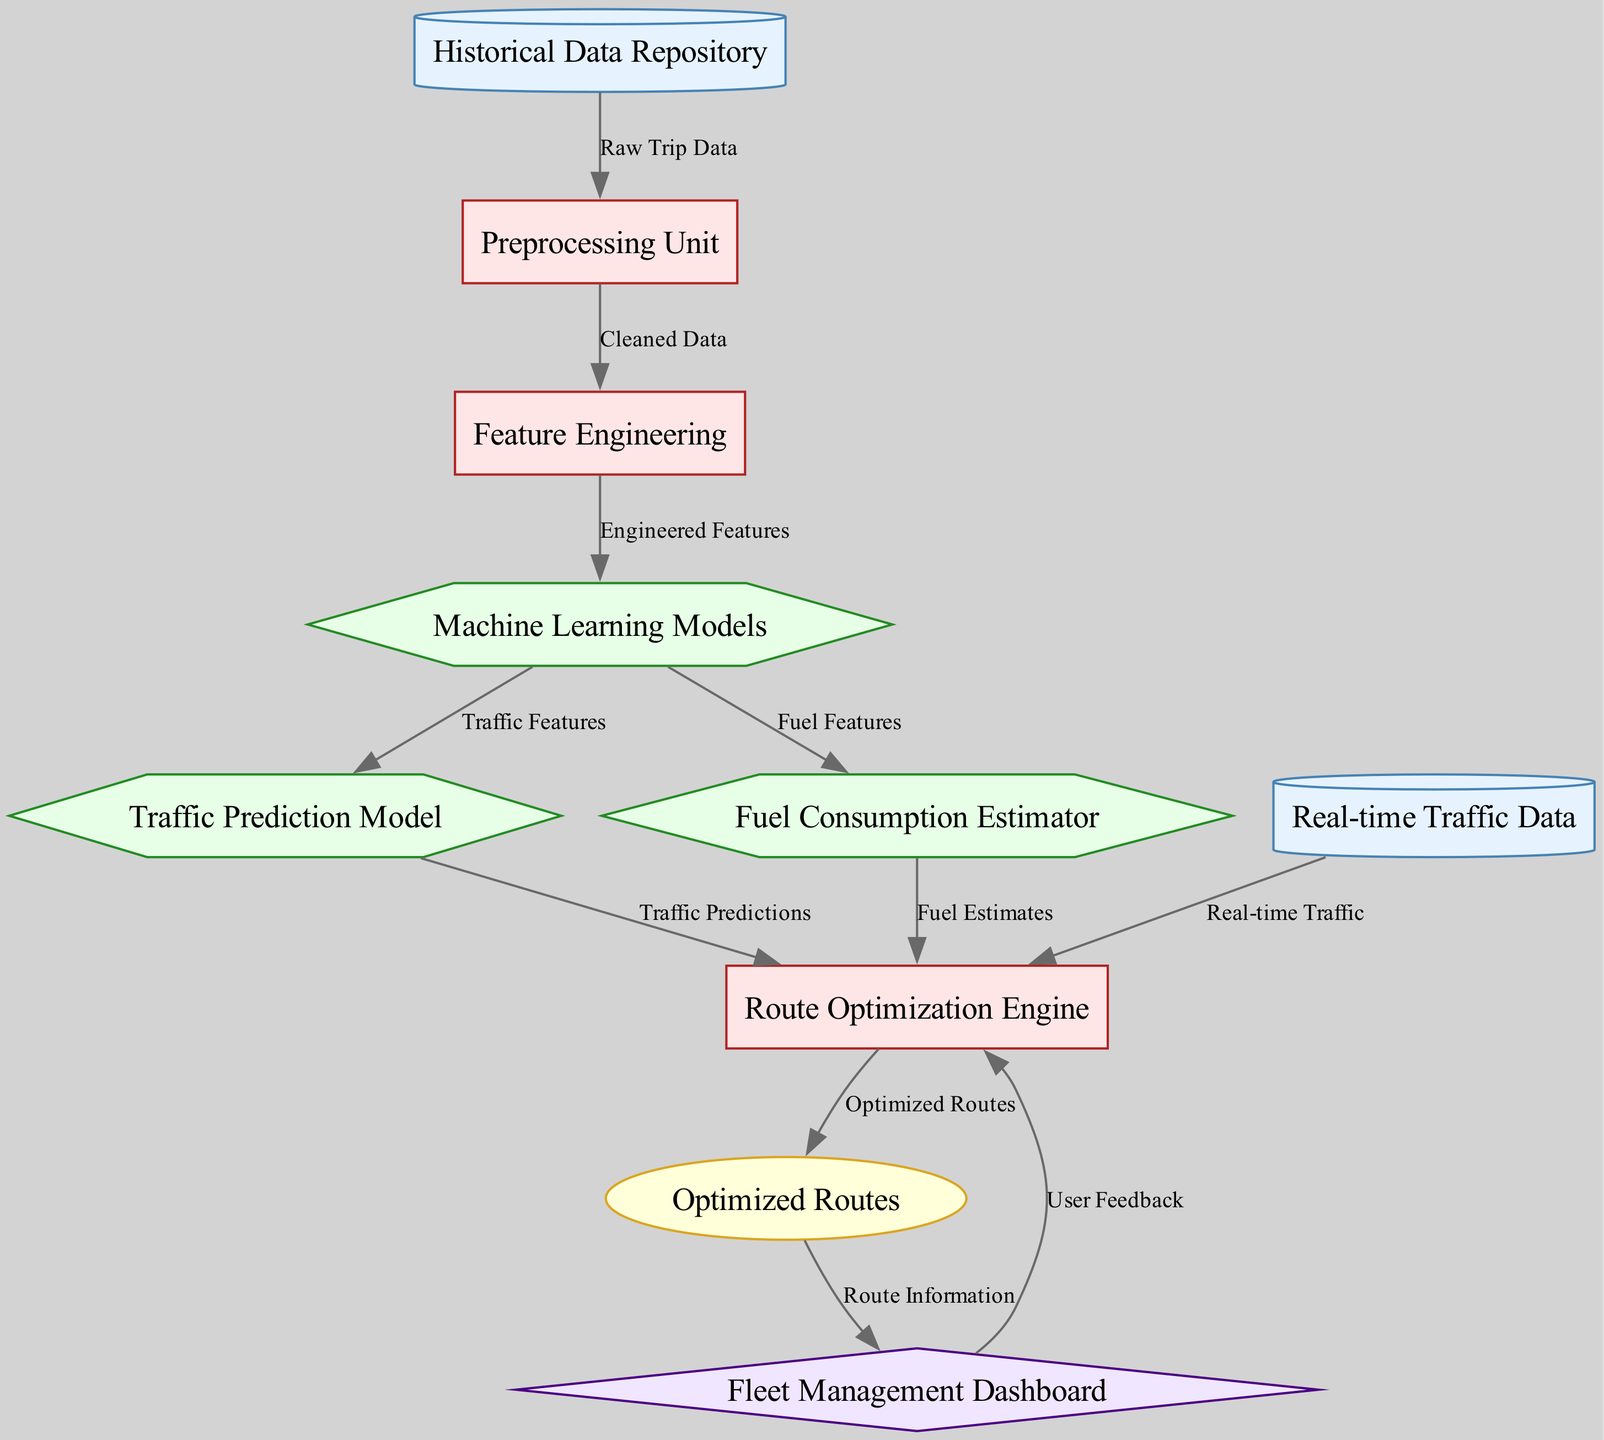What is the type of the first node? The first node is labeled "Historical Data Repository," and based on the diagram, it is categorized as a data source.
Answer: data source How many machine learning models are represented in the diagram? The diagram shows three machine learning models: "Machine Learning Models," "Traffic Prediction Model," and "Fuel Consumption Estimator." Therefore, there are three models.
Answer: three What does the "Preprocessing Unit" output? The "Preprocessing Unit" receives raw trip data from the "Historical Data Repository" and outputs cleaned data.
Answer: cleaned data Which node receives real-time traffic data? The "Route Optimization Engine" node receives real-time traffic data, which is indicated by the directed edge from the "Real-time Traffic Data" data source to the "Route Optimization Engine."
Answer: Route Optimization Engine What is the final output of the route optimization process? The final output of the route optimization process is represented by the "Optimized Routes" node.
Answer: Optimized Routes What type of data does the "Historical Data Repository" provide? The "Historical Data Repository" provides raw trip data, which is the initial input to the system.
Answer: raw trip data How do the Traffic Prediction Model and Fuel Consumption Estimator connect to the Route Optimization Engine? Both the "Traffic Prediction Model" and "Fuel Consumption Estimator" feed their respective predictions and estimates into the "Route Optimization Engine," enabling it to use traffic predictions and fuel estimates for generating optimized routes.
Answer: Through predictions and estimates What type of interface is used to display the optimized routes? The "Fleet Management Dashboard" node serves as the interface to display the optimized routes, making it the designated output interface.
Answer: Fleet Management Dashboard What type of edge connects the "Fleet Management Dashboard" and the "Route Optimization Engine"? The edge connecting the "Fleet Management Dashboard" to the "Route Optimization Engine" represents route information passing from the optimized routes to the user interface for display.
Answer: Route Information 